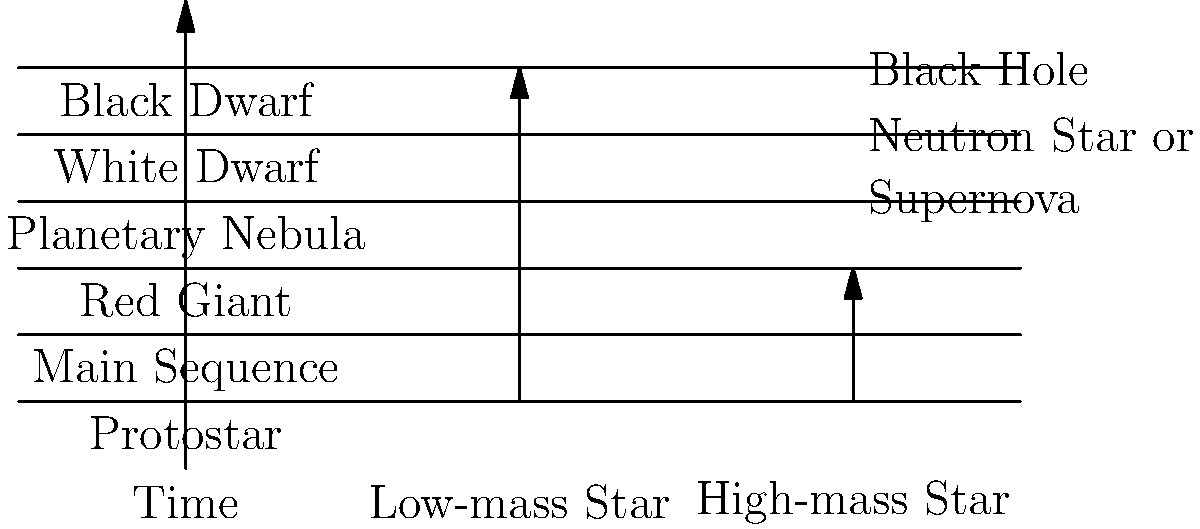In the life cycle of stars, what stage immediately follows the Red Giant phase for a low-mass star like our Sun? To answer this question, let's follow the life cycle of a low-mass star like our Sun:

1. The star begins as a Protostar, collapsing under gravity.
2. It then enters the Main Sequence stage, where it spends most of its life fusing hydrogen into helium in its core.
3. When the hydrogen in the core is depleted, the star expands and cools, becoming a Red Giant.
4. After the Red Giant phase, the star sheds its outer layers, creating a Planetary Nebula.
5. The core of the star remains as a White Dwarf.
6. Over an extremely long time, the White Dwarf cools to become a Black Dwarf.

For a low-mass star like our Sun, the stage immediately following the Red Giant phase is the Planetary Nebula. This is when the star ejects its outer layers, exposing its hot core.

It's important to note that high-mass stars follow a different path after the Red Giant stage, leading to a Supernova explosion and potentially forming a Neutron Star or Black Hole.
Answer: Planetary Nebula 